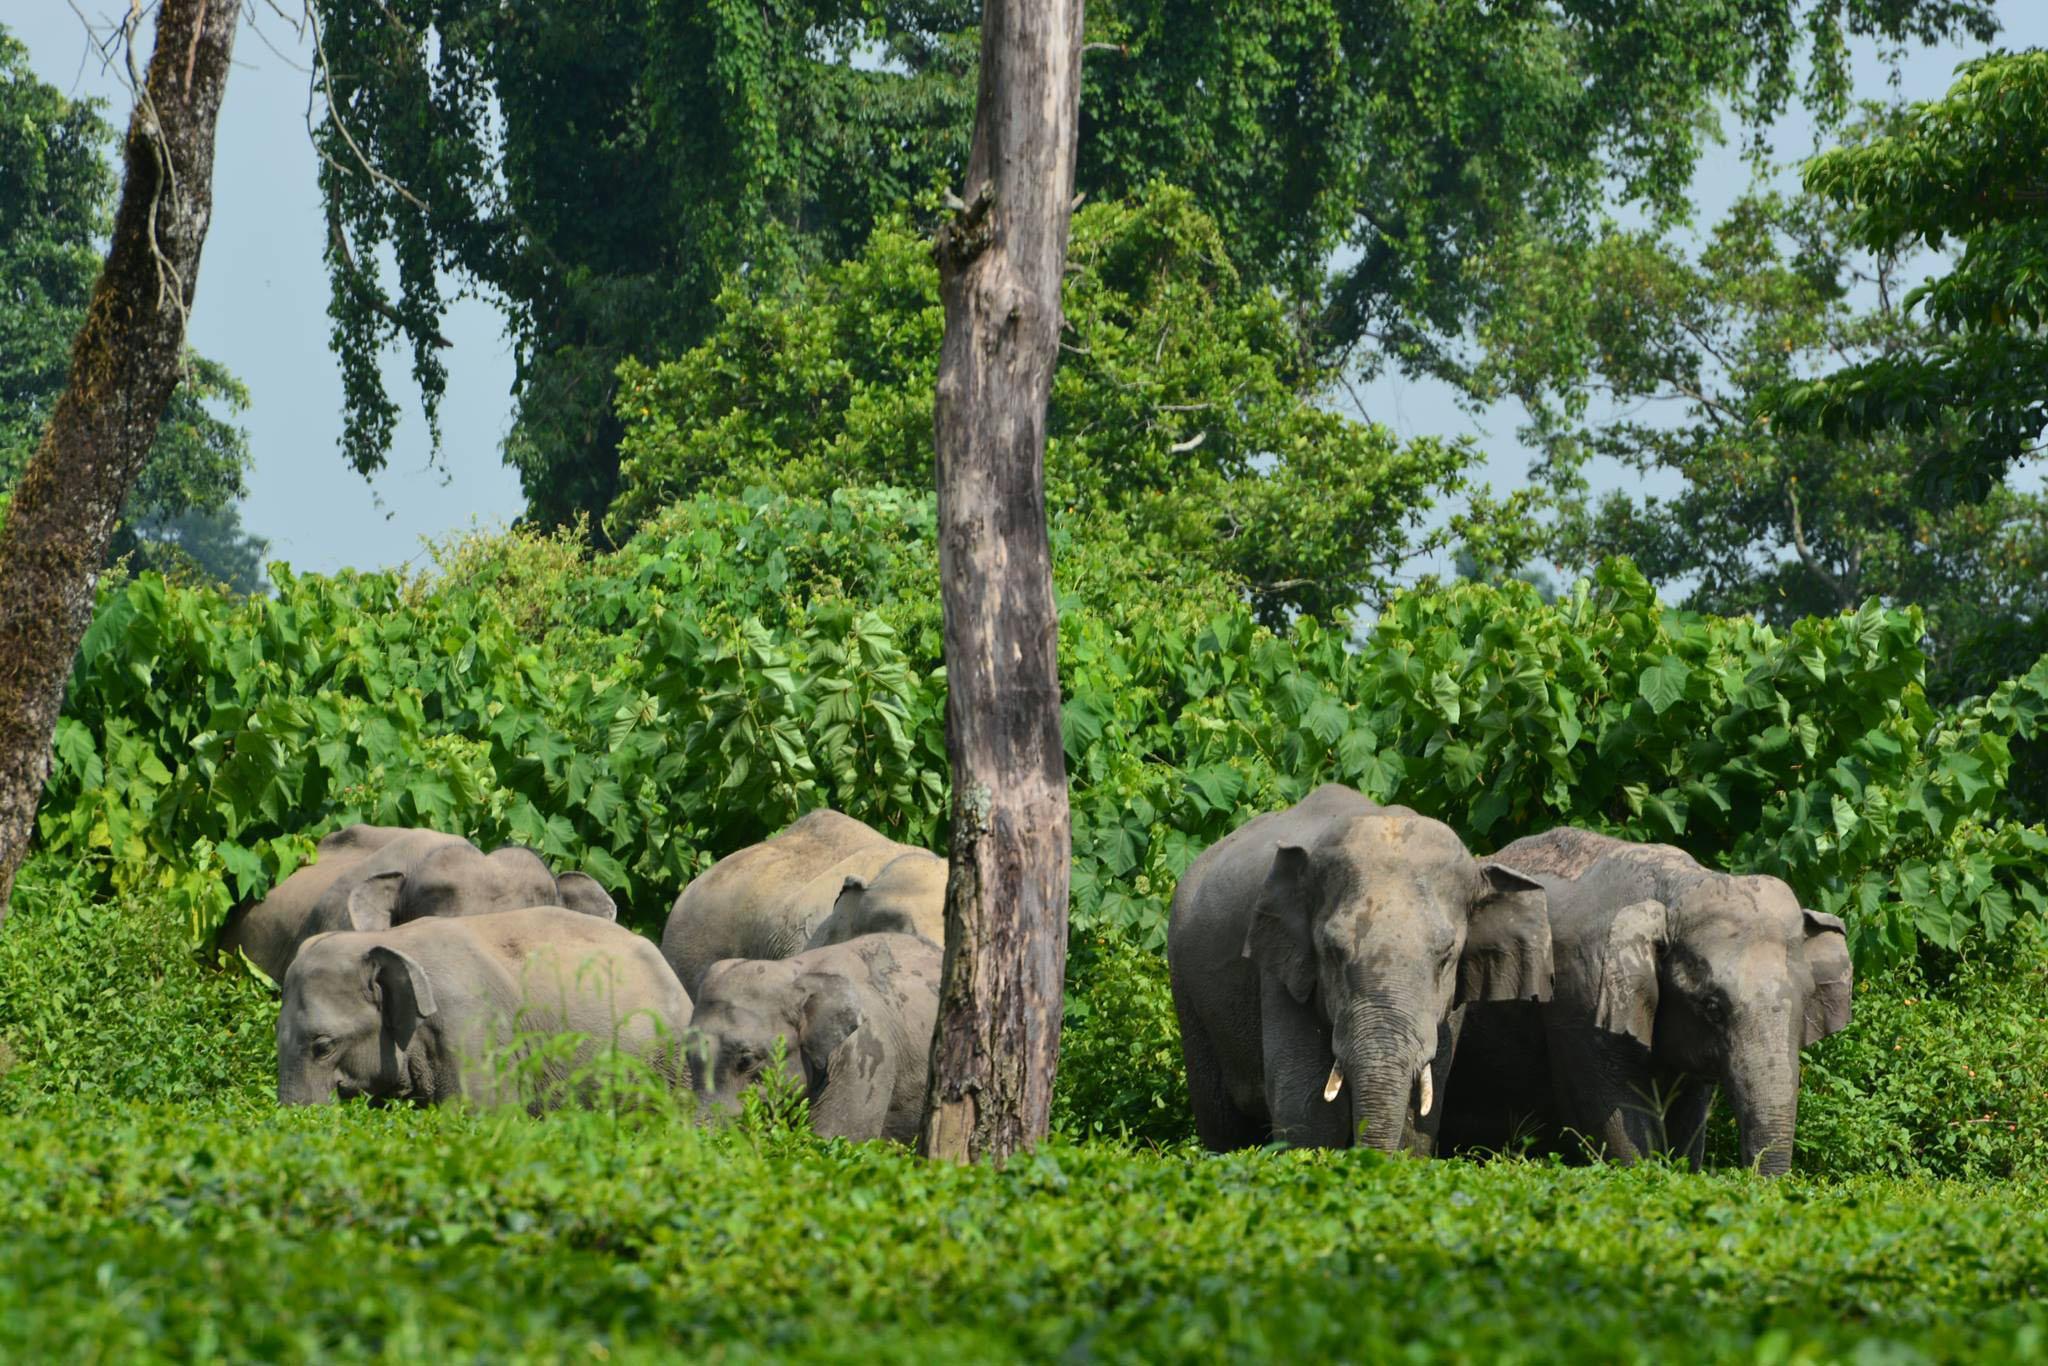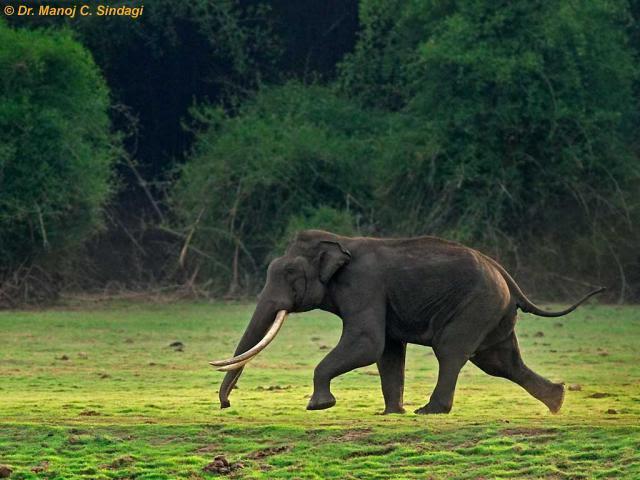The first image is the image on the left, the second image is the image on the right. For the images displayed, is the sentence "One image shows at least one elephant standing in a wet area." factually correct? Answer yes or no. No. 